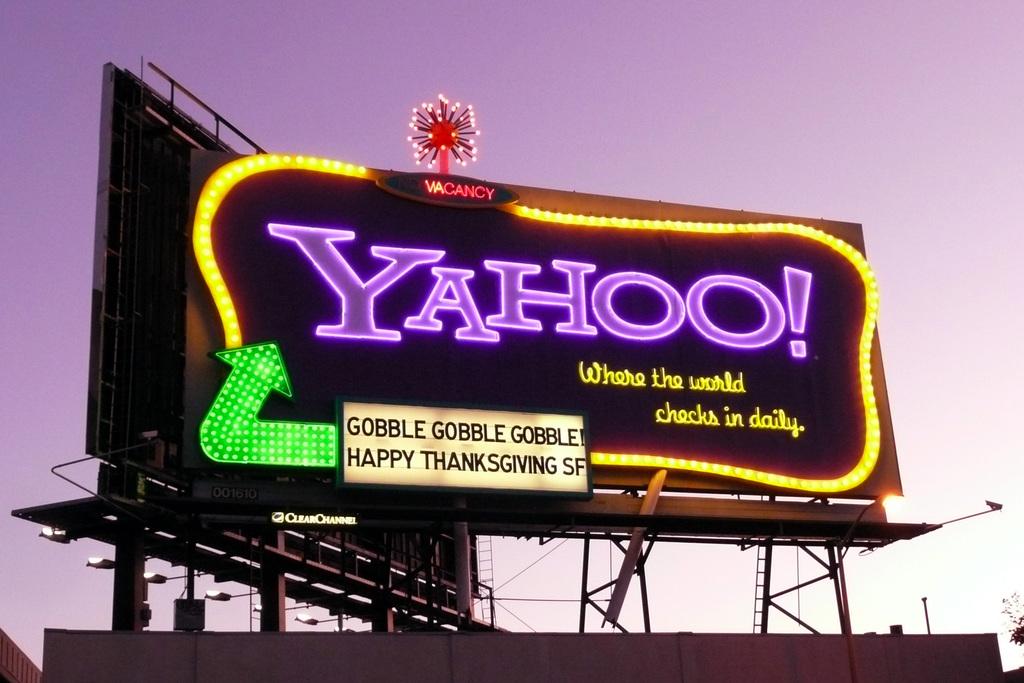What is written in the pink letters?
Your answer should be very brief. Yahoo. What company is advertised on this billboard?
Offer a very short reply. Yahoo. 